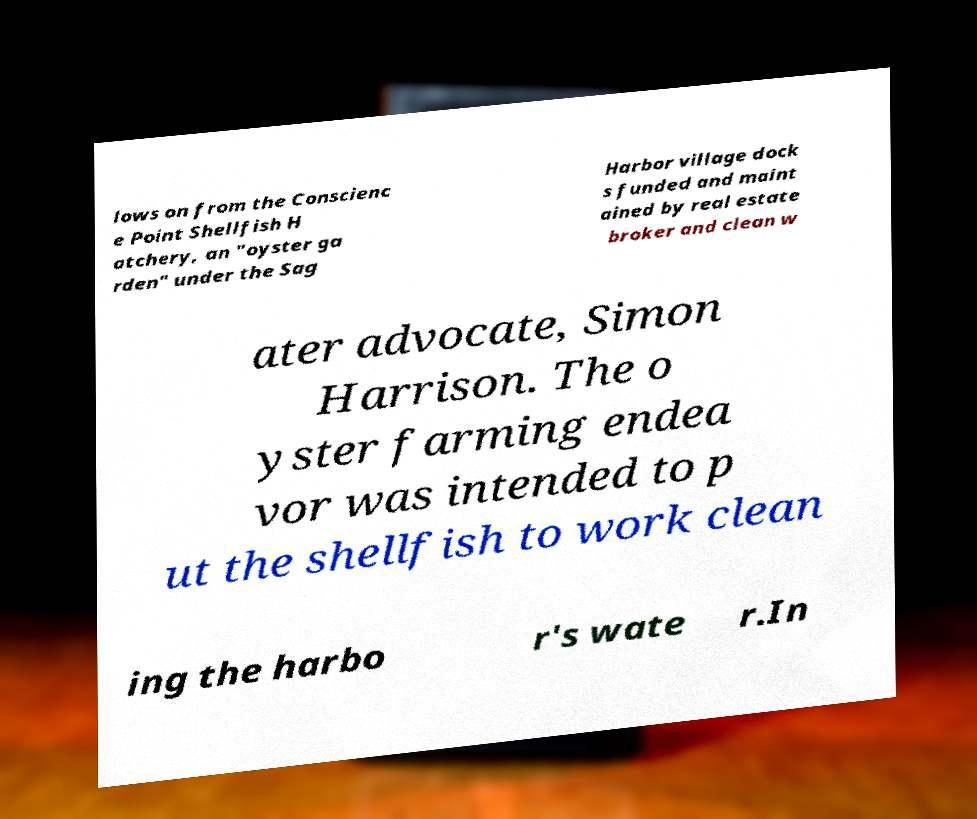Can you accurately transcribe the text from the provided image for me? lows on from the Conscienc e Point Shellfish H atchery, an "oyster ga rden" under the Sag Harbor village dock s funded and maint ained by real estate broker and clean w ater advocate, Simon Harrison. The o yster farming endea vor was intended to p ut the shellfish to work clean ing the harbo r's wate r.In 